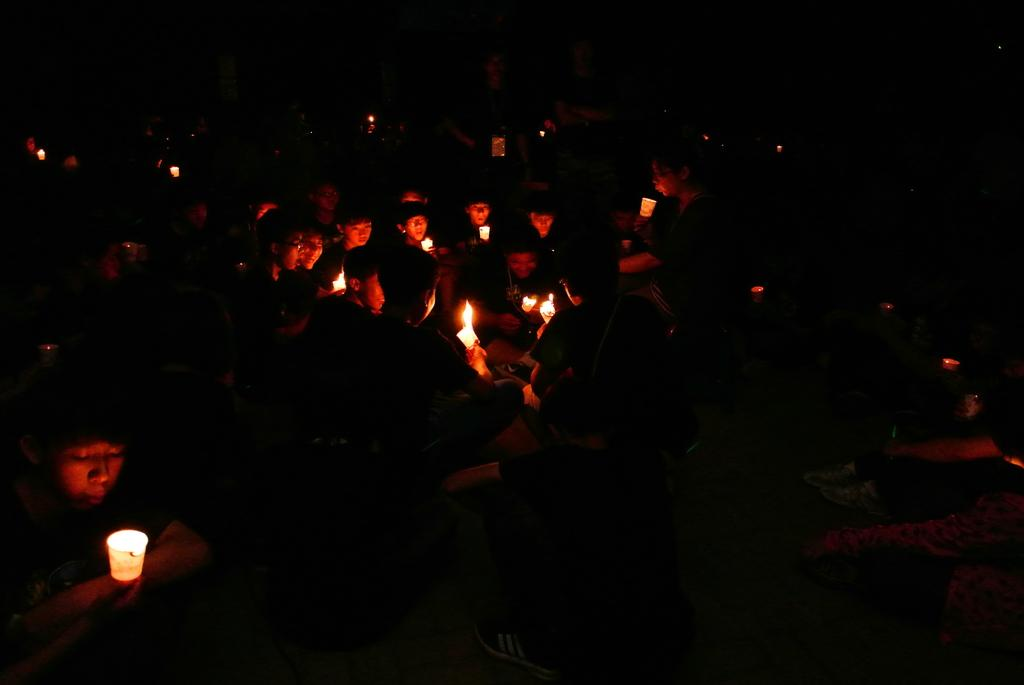What is the overall lighting condition in the image? The image is dark. What are the people in the image doing? The people are sitting in the image. What objects are the people holding in the image? The people are holding candles. What time of day is represented by the hour in the image? There is no hour present in the image, as it is a dark scene with people holding candles. What type of books are being read by the people in the image? There are no books visible in the image; the people are holding candles. 